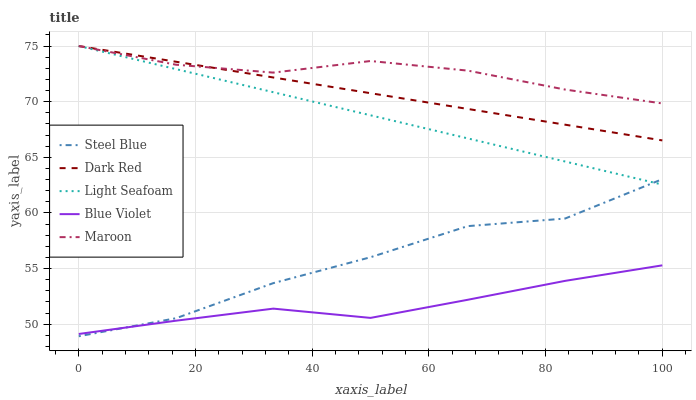Does Blue Violet have the minimum area under the curve?
Answer yes or no. Yes. Does Maroon have the maximum area under the curve?
Answer yes or no. Yes. Does Dark Red have the minimum area under the curve?
Answer yes or no. No. Does Dark Red have the maximum area under the curve?
Answer yes or no. No. Is Dark Red the smoothest?
Answer yes or no. Yes. Is Steel Blue the roughest?
Answer yes or no. Yes. Is Light Seafoam the smoothest?
Answer yes or no. No. Is Light Seafoam the roughest?
Answer yes or no. No. Does Steel Blue have the lowest value?
Answer yes or no. Yes. Does Dark Red have the lowest value?
Answer yes or no. No. Does Light Seafoam have the highest value?
Answer yes or no. Yes. Does Steel Blue have the highest value?
Answer yes or no. No. Is Steel Blue less than Maroon?
Answer yes or no. Yes. Is Maroon greater than Steel Blue?
Answer yes or no. Yes. Does Light Seafoam intersect Maroon?
Answer yes or no. Yes. Is Light Seafoam less than Maroon?
Answer yes or no. No. Is Light Seafoam greater than Maroon?
Answer yes or no. No. Does Steel Blue intersect Maroon?
Answer yes or no. No. 